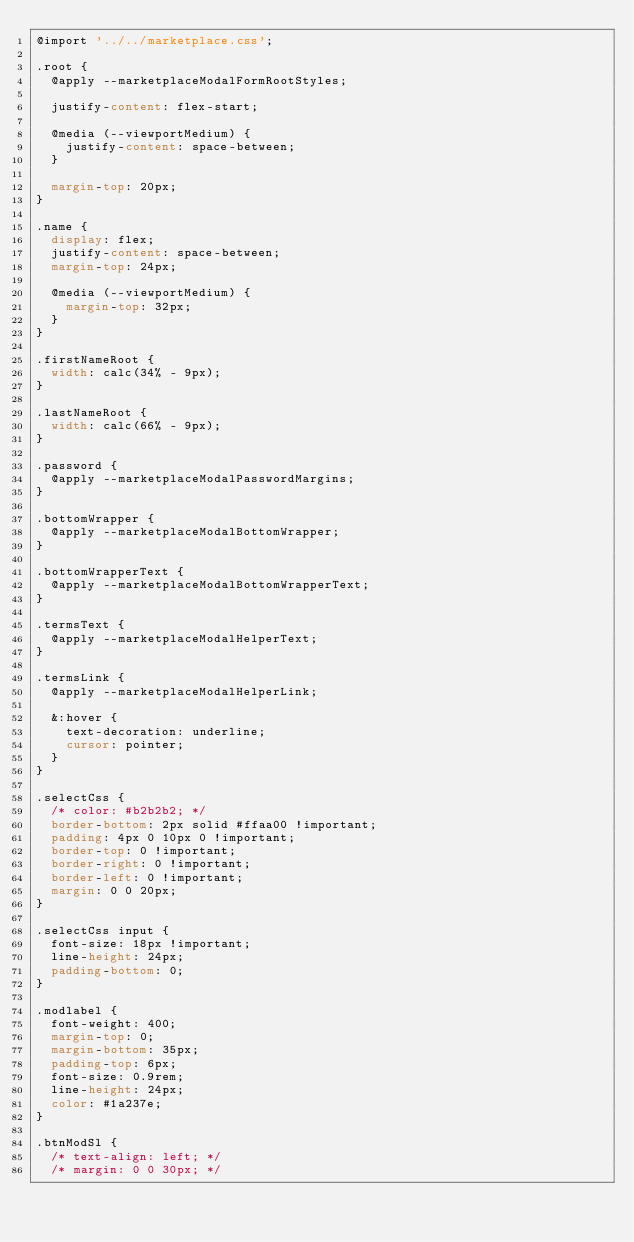Convert code to text. <code><loc_0><loc_0><loc_500><loc_500><_CSS_>@import '../../marketplace.css';

.root {
  @apply --marketplaceModalFormRootStyles;

  justify-content: flex-start;

  @media (--viewportMedium) {
    justify-content: space-between;
  }

  margin-top: 20px;
}

.name {
  display: flex;
  justify-content: space-between;
  margin-top: 24px;

  @media (--viewportMedium) {
    margin-top: 32px;
  }
}

.firstNameRoot {
  width: calc(34% - 9px);
}

.lastNameRoot {
  width: calc(66% - 9px);
}

.password {
  @apply --marketplaceModalPasswordMargins;
}

.bottomWrapper {
  @apply --marketplaceModalBottomWrapper;
}

.bottomWrapperText {
  @apply --marketplaceModalBottomWrapperText;
}

.termsText {
  @apply --marketplaceModalHelperText;
}

.termsLink {
  @apply --marketplaceModalHelperLink;

  &:hover {
    text-decoration: underline;
    cursor: pointer;
  }
}

.selectCss {
  /* color: #b2b2b2; */
  border-bottom: 2px solid #ffaa00 !important;
  padding: 4px 0 10px 0 !important;
  border-top: 0 !important;
  border-right: 0 !important;
  border-left: 0 !important;
  margin: 0 0 20px;
}

.selectCss input {
  font-size: 18px !important;
  line-height: 24px;
  padding-bottom: 0;
}

.modlabel {
  font-weight: 400;
  margin-top: 0;
  margin-bottom: 35px;
  padding-top: 6px;
  font-size: 0.9rem;
  line-height: 24px;
  color: #1a237e;
}

.btnModSl {
  /* text-align: left; */
  /* margin: 0 0 30px; */</code> 